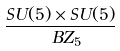<formula> <loc_0><loc_0><loc_500><loc_500>\frac { S U ( 5 ) \times S U ( 5 ) } { \ B Z _ { 5 } }</formula> 